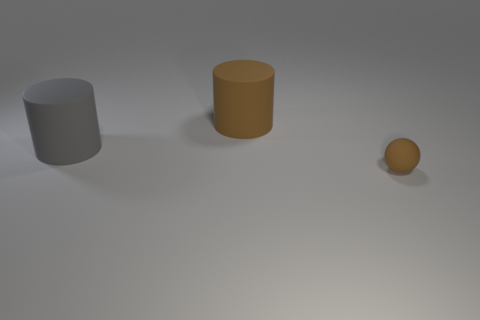Add 3 gray objects. How many objects exist? 6 Subtract all balls. How many objects are left? 2 Add 2 large yellow matte balls. How many large yellow matte balls exist? 2 Subtract 0 cyan cubes. How many objects are left? 3 Subtract all gray rubber cylinders. Subtract all large gray cylinders. How many objects are left? 1 Add 2 large brown rubber things. How many large brown rubber things are left? 3 